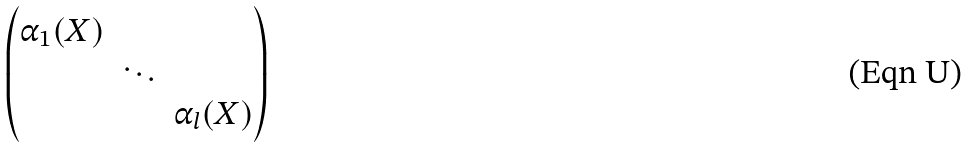Convert formula to latex. <formula><loc_0><loc_0><loc_500><loc_500>\begin{pmatrix} \alpha _ { 1 } ( X ) \\ & \ddots \\ & & \alpha _ { l } ( X ) \end{pmatrix}</formula> 